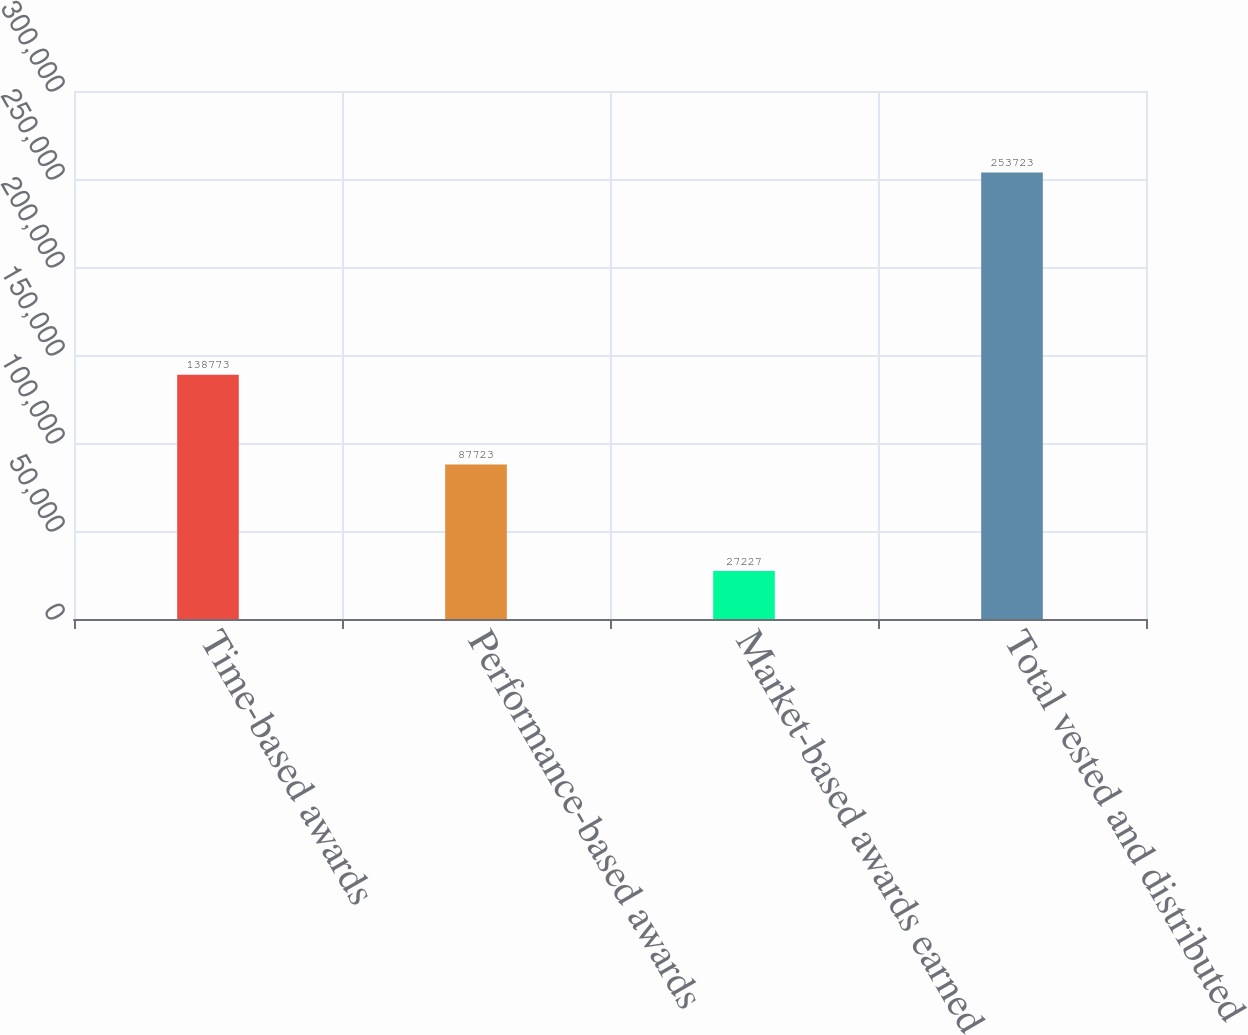Convert chart. <chart><loc_0><loc_0><loc_500><loc_500><bar_chart><fcel>Time-based awards<fcel>Performance-based awards<fcel>Market-based awards earned<fcel>Total vested and distributed<nl><fcel>138773<fcel>87723<fcel>27227<fcel>253723<nl></chart> 